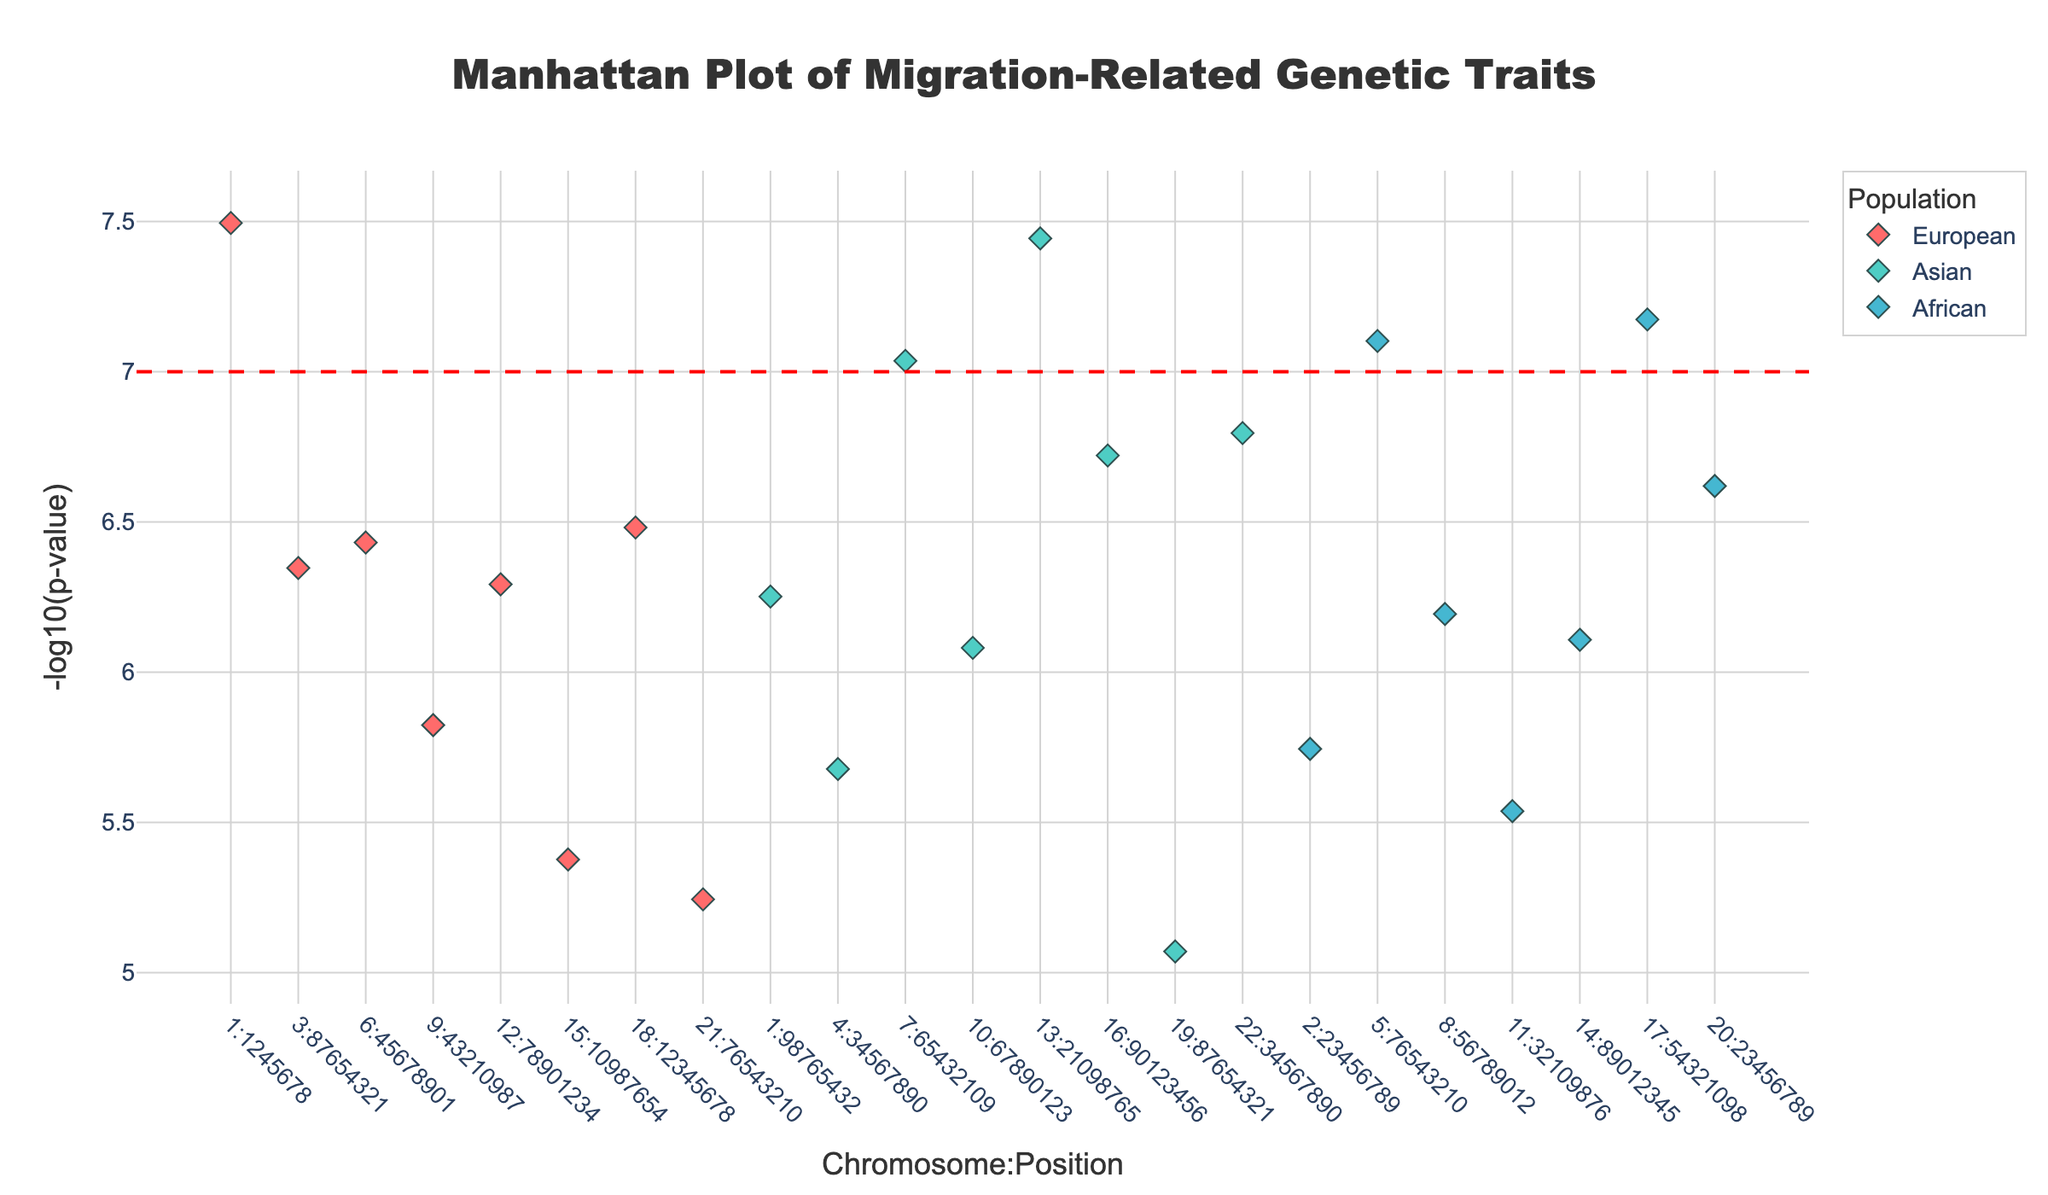what is the title of the plot? The title of the plot is displayed prominently at the top of the figure. It is set using the 'title' attribute in the figure layout.
Answer: Manhattan Plot of Migration-Related Genetic Traits Which population has the most significant genetic trait in terms of -log10(p-value)? Look for the data point that has the highest -log10(p-value) value and check its population based on the marker color and the hover information.
Answer: European What is the highest -log10(p-value) value observed in the plot? Identify the data point with the maximum y-value on the plot. This value represents the highest -log10(p-value).
Answer: 7.5 How many traits have a P-value less than 5x10^-8? Identify points above the horizontal significance threshold line (y=7 on -log10 scale) and count them. Each of these represents a trait with P-value < 5x10^-8.
Answer: 4 Which chromosome positions correspond to the highest significance values for the Asian population? Filter the data points by population color and check for the largest y-values, then match these with the chromosome positions using the x-axis labels and hover information.
Answer: 13:21098765, 22:34567890, and 7:65432109 What trait is associated with the SNP rs4988235 and which population does it belong to? Identify the SNP rs4988235 in the plot by hovering over the points or referring to the hover information. Note down the associated trait and population.
Answer: Adaptation to new environments, Asian Which population appears to have the most genetic traits associated with migration across different chromosome positions? Count the number of data points (markers) associated with each population and compare them.
Answer: Asian What is the population of the genetic trait with SNP rs1815739 and what trait does it represent? Locate the SNP rs1815739 on the plot and use the hover information to determine its associated trait and population.
Answer: Risk-taking behavior, African For the European population, what is the range of -log10(p-value) observed for their genetic traits? Identify the data points associated with the European population, find the minimum and maximum y-values, and calculate the range.
Answer: 2.05 to 7.495 Which population has a trait linked to the SNP rs1042778 and what is that trait? Find the SNP rs1042778 in the plot, and use the hover information or the marker's color to determine the trait and population.
Answer: Social network formation, African 